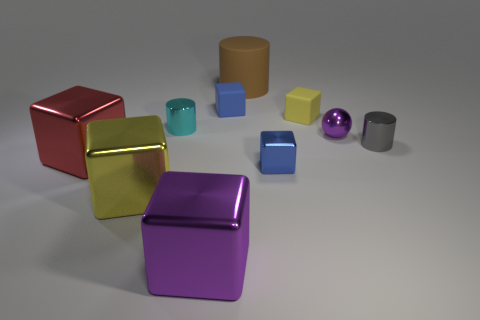What is the color of the small cylinder on the right side of the small blue metallic block?
Ensure brevity in your answer.  Gray. Do the shiny ball and the small metal cube have the same color?
Ensure brevity in your answer.  No. How many tiny blue things are behind the purple object that is right of the metallic block that is to the right of the purple block?
Your answer should be compact. 1. How big is the brown thing?
Your answer should be very brief. Large. What is the material of the gray thing that is the same size as the purple ball?
Your response must be concise. Metal. What number of blue objects are left of the brown thing?
Offer a very short reply. 1. Does the tiny ball to the right of the big brown cylinder have the same material as the purple thing that is on the left side of the small blue rubber thing?
Make the answer very short. Yes. There is a small blue thing left of the brown rubber thing behind the small cylinder that is left of the big purple metallic cube; what shape is it?
Make the answer very short. Cube. The tiny gray metal thing has what shape?
Your answer should be compact. Cylinder. There is a matte thing that is the same size as the red block; what is its shape?
Offer a very short reply. Cylinder. 